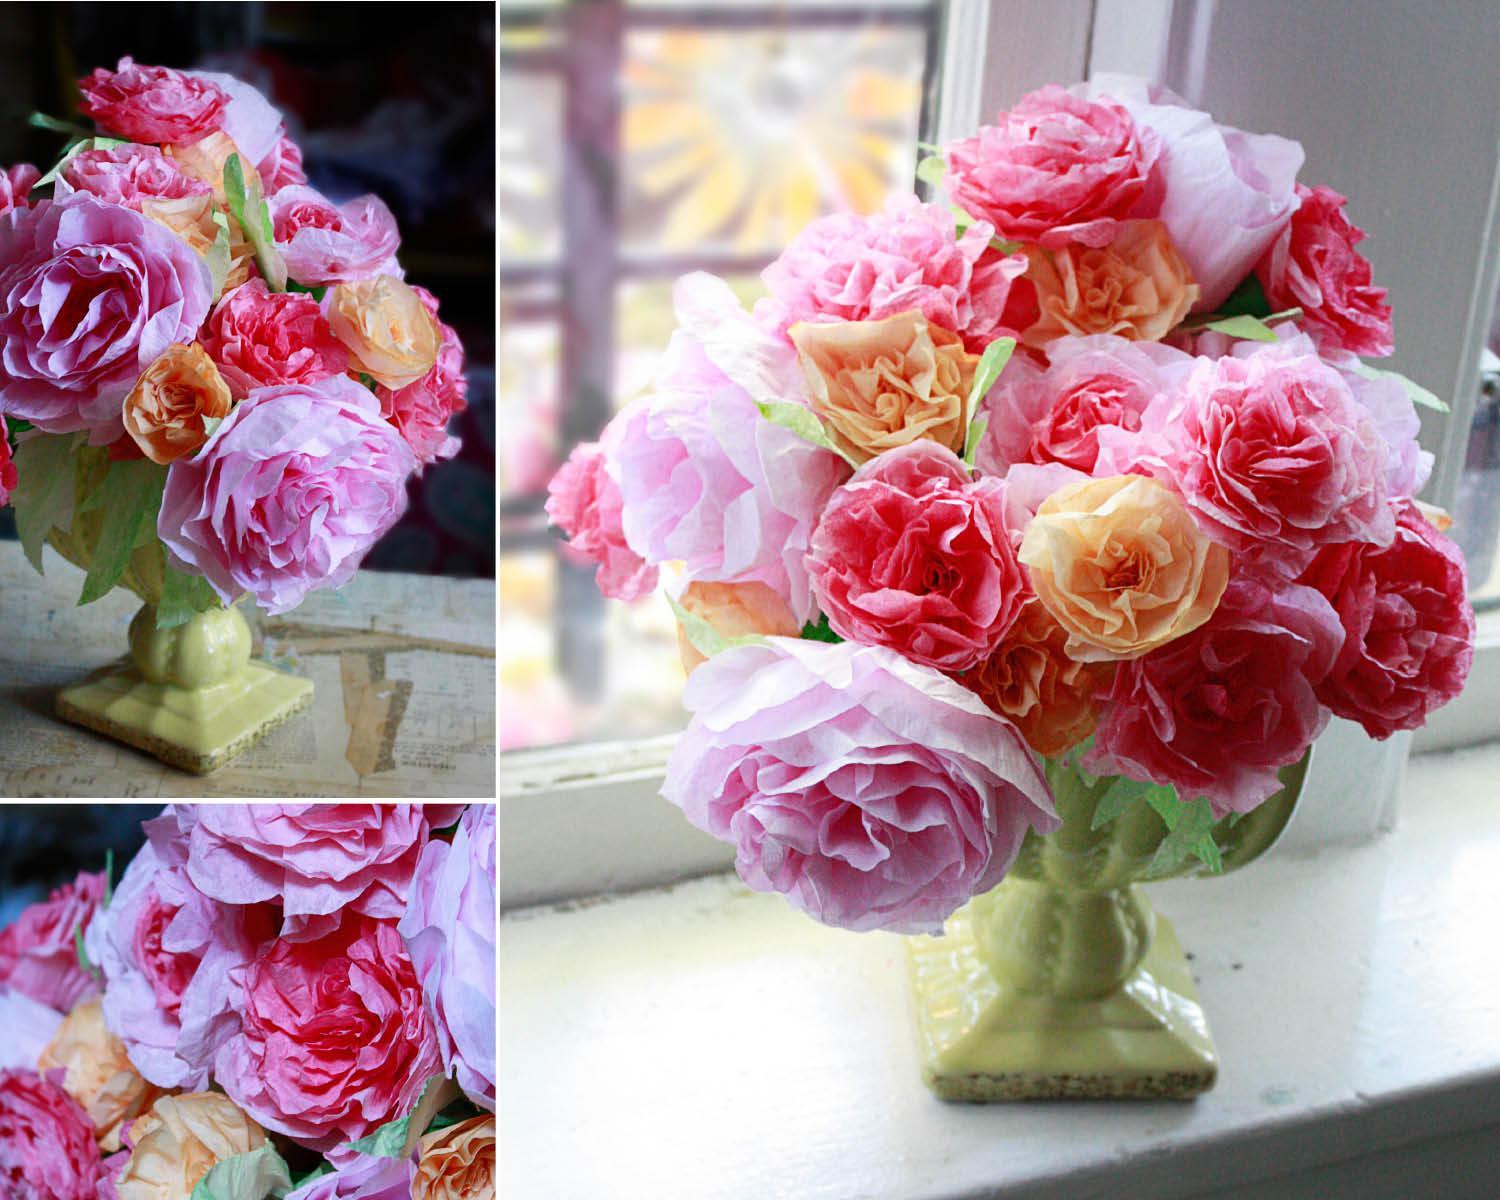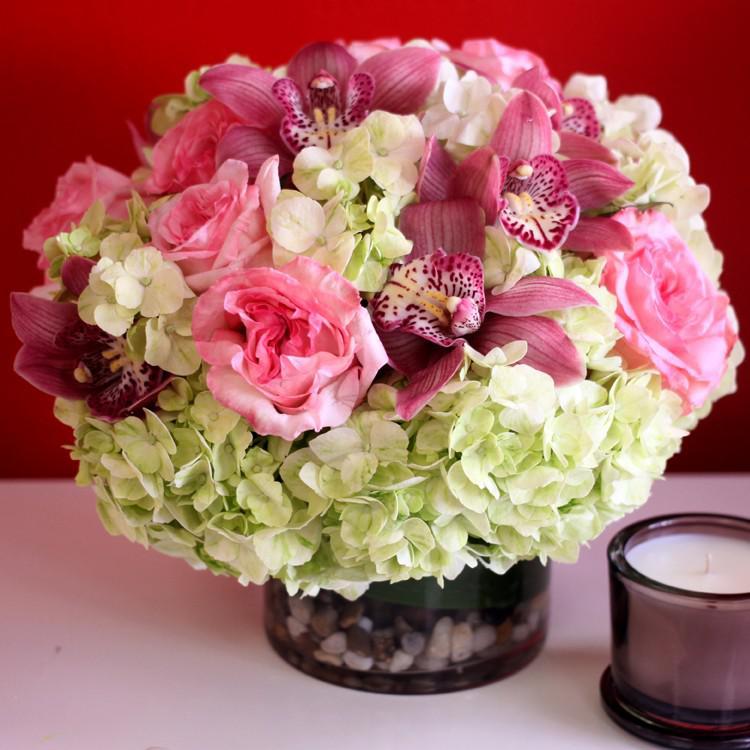The first image is the image on the left, the second image is the image on the right. Analyze the images presented: Is the assertion "There are stones at the bottom of one of the vases." valid? Answer yes or no. Yes. The first image is the image on the left, the second image is the image on the right. Assess this claim about the two images: "One image shows a transparent cylindrical vase with pebble-shaped objects inside, holding a bouquet of pink roses and ruffly white flowers.". Correct or not? Answer yes or no. Yes. 